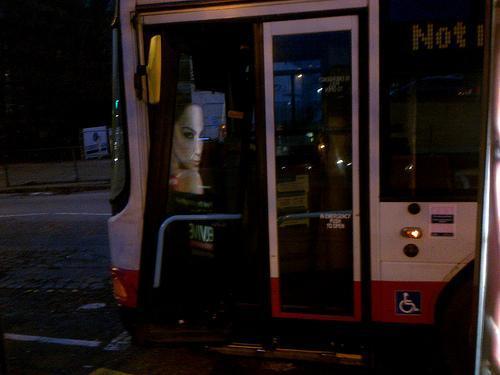How many buses are there?
Give a very brief answer. 1. 